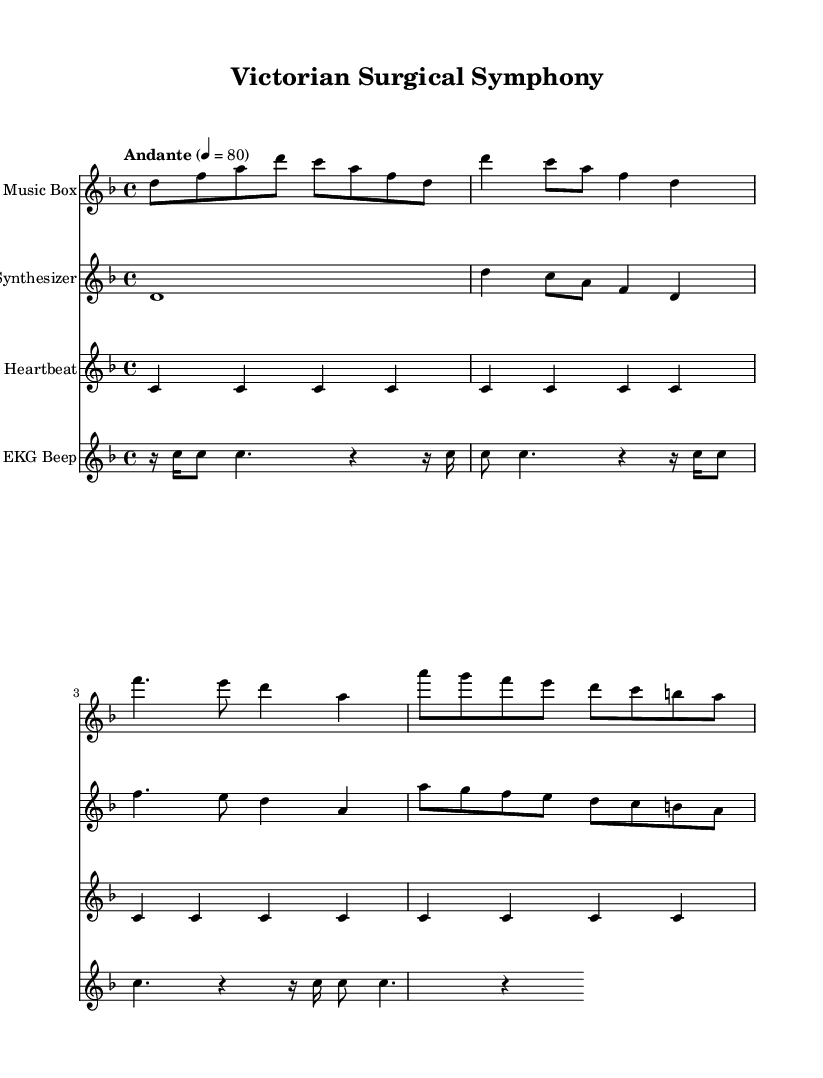What is the key signature of this music? The key signature is D minor, which contains one flat (B flat) and indicates a darker, more somber tonality.
Answer: D minor What is the time signature of this music? The time signature is 4/4, which means there are four beats in each measure, and the quarter note receives one beat.
Answer: 4/4 What is the tempo marking of this music? The tempo marking is "Andante," which indicates a moderately slow tempo, typically around 76-108 beats per minute.
Answer: Andante How many measures are in the "musicBox" section? The "musicBox" section contains 4 measures, as indicated by the grouping of notes within the staff.
Answer: 4 Which instrument plays the heartbeat monitor part? The heartbeat monitor part is indicated as belonging to a "Heartbeat," which aligns with the medical theme and adds an organic rhythmic element.
Answer: Heartbeat What are the dynamics indicated for the "synthesizer" part? The "synthesizer" part does not indicate any specific dynamics, suggesting a consistent, possibly electronic sound throughout.
Answer: No specific dynamics What might the EKG beep represent in this piece? The EKG beep, notated as rhythmic rests and notes, likely emulates the sound of medical monitoring equipment, contrasting with the Victorian elements in the composition.
Answer: Medical monitoring 